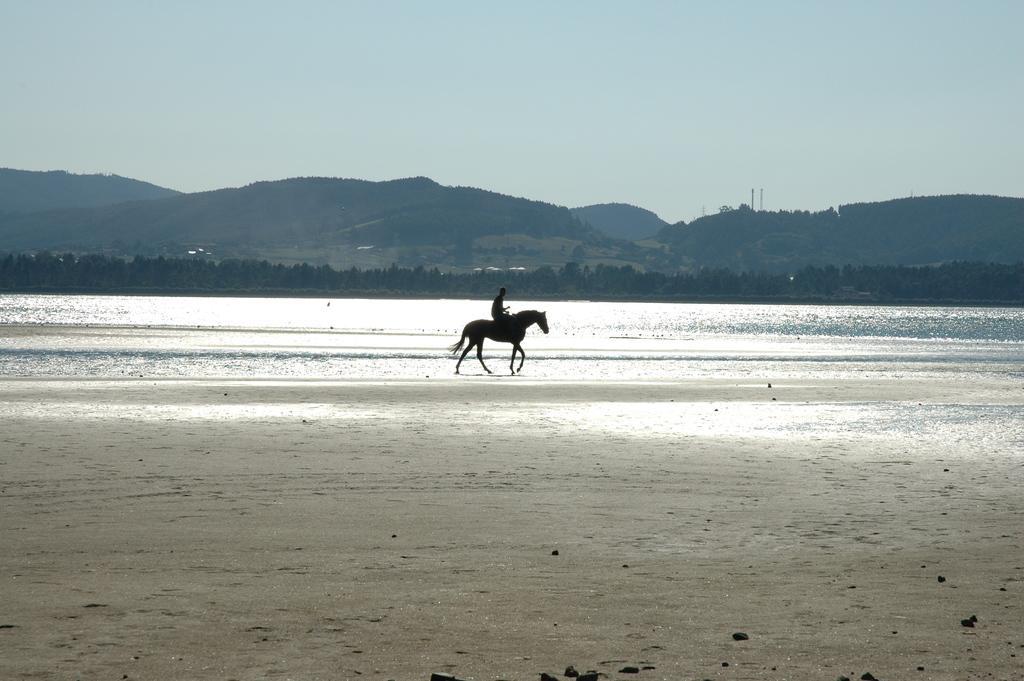In one or two sentences, can you explain what this image depicts? In the center of the image we can see a person sitting on the horse. In the background there is a sea, trees, hills and sky. At the bottom there is a seashore. 